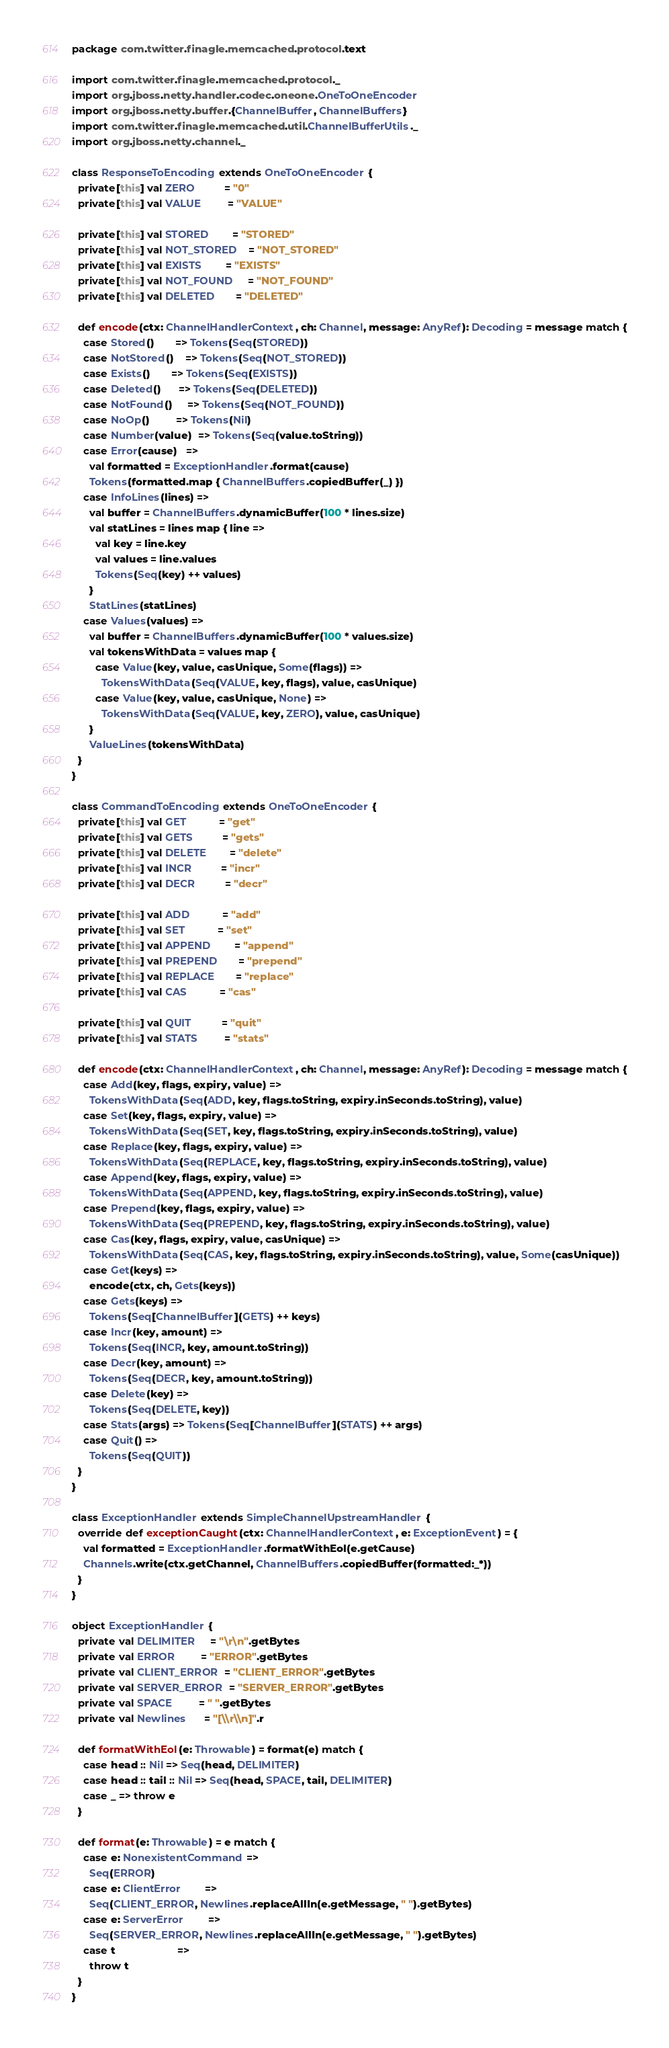<code> <loc_0><loc_0><loc_500><loc_500><_Scala_>package com.twitter.finagle.memcached.protocol.text

import com.twitter.finagle.memcached.protocol._
import org.jboss.netty.handler.codec.oneone.OneToOneEncoder
import org.jboss.netty.buffer.{ChannelBuffer, ChannelBuffers}
import com.twitter.finagle.memcached.util.ChannelBufferUtils._
import org.jboss.netty.channel._

class ResponseToEncoding extends OneToOneEncoder {
  private[this] val ZERO          = "0"
  private[this] val VALUE         = "VALUE"

  private[this] val STORED        = "STORED"
  private[this] val NOT_STORED    = "NOT_STORED"
  private[this] val EXISTS        = "EXISTS"
  private[this] val NOT_FOUND     = "NOT_FOUND"
  private[this] val DELETED       = "DELETED"

  def encode(ctx: ChannelHandlerContext, ch: Channel, message: AnyRef): Decoding = message match {
    case Stored()       => Tokens(Seq(STORED))
    case NotStored()    => Tokens(Seq(NOT_STORED))
    case Exists()       => Tokens(Seq(EXISTS))
    case Deleted()      => Tokens(Seq(DELETED))
    case NotFound()     => Tokens(Seq(NOT_FOUND))
    case NoOp()         => Tokens(Nil)
    case Number(value)  => Tokens(Seq(value.toString))
    case Error(cause)   =>
      val formatted = ExceptionHandler.format(cause)
      Tokens(formatted.map { ChannelBuffers.copiedBuffer(_) })
    case InfoLines(lines) =>
      val buffer = ChannelBuffers.dynamicBuffer(100 * lines.size)
      val statLines = lines map { line =>
        val key = line.key
        val values = line.values
        Tokens(Seq(key) ++ values)
      }
      StatLines(statLines)
    case Values(values) =>
      val buffer = ChannelBuffers.dynamicBuffer(100 * values.size)
      val tokensWithData = values map {
        case Value(key, value, casUnique, Some(flags)) =>
          TokensWithData(Seq(VALUE, key, flags), value, casUnique)
        case Value(key, value, casUnique, None) =>
          TokensWithData(Seq(VALUE, key, ZERO), value, casUnique)
      }
      ValueLines(tokensWithData)
  }
}

class CommandToEncoding extends OneToOneEncoder {
  private[this] val GET           = "get"
  private[this] val GETS          = "gets"
  private[this] val DELETE        = "delete"
  private[this] val INCR          = "incr"
  private[this] val DECR          = "decr"

  private[this] val ADD           = "add"
  private[this] val SET           = "set"
  private[this] val APPEND        = "append"
  private[this] val PREPEND       = "prepend"
  private[this] val REPLACE       = "replace"
  private[this] val CAS           = "cas"

  private[this] val QUIT          = "quit"
  private[this] val STATS         = "stats"

  def encode(ctx: ChannelHandlerContext, ch: Channel, message: AnyRef): Decoding = message match {
    case Add(key, flags, expiry, value) =>
      TokensWithData(Seq(ADD, key, flags.toString, expiry.inSeconds.toString), value)
    case Set(key, flags, expiry, value) =>
      TokensWithData(Seq(SET, key, flags.toString, expiry.inSeconds.toString), value)
    case Replace(key, flags, expiry, value) =>
      TokensWithData(Seq(REPLACE, key, flags.toString, expiry.inSeconds.toString), value)
    case Append(key, flags, expiry, value) =>
      TokensWithData(Seq(APPEND, key, flags.toString, expiry.inSeconds.toString), value)
    case Prepend(key, flags, expiry, value) =>
      TokensWithData(Seq(PREPEND, key, flags.toString, expiry.inSeconds.toString), value)
    case Cas(key, flags, expiry, value, casUnique) =>
      TokensWithData(Seq(CAS, key, flags.toString, expiry.inSeconds.toString), value, Some(casUnique))
    case Get(keys) =>
      encode(ctx, ch, Gets(keys))
    case Gets(keys) =>
      Tokens(Seq[ChannelBuffer](GETS) ++ keys)
    case Incr(key, amount) =>
      Tokens(Seq(INCR, key, amount.toString))
    case Decr(key, amount) =>
      Tokens(Seq(DECR, key, amount.toString))
    case Delete(key) =>
      Tokens(Seq(DELETE, key))
    case Stats(args) => Tokens(Seq[ChannelBuffer](STATS) ++ args)
    case Quit() =>
      Tokens(Seq(QUIT))
  }
}

class ExceptionHandler extends SimpleChannelUpstreamHandler {
  override def exceptionCaught(ctx: ChannelHandlerContext, e: ExceptionEvent) = {
    val formatted = ExceptionHandler.formatWithEol(e.getCause)
    Channels.write(ctx.getChannel, ChannelBuffers.copiedBuffer(formatted:_*))
  }
}

object ExceptionHandler {
  private val DELIMITER     = "\r\n".getBytes
  private val ERROR         = "ERROR".getBytes
  private val CLIENT_ERROR  = "CLIENT_ERROR".getBytes
  private val SERVER_ERROR  = "SERVER_ERROR".getBytes
  private val SPACE         = " ".getBytes
  private val Newlines      = "[\\r\\n]".r

  def formatWithEol(e: Throwable) = format(e) match {
    case head :: Nil => Seq(head, DELIMITER)
    case head :: tail :: Nil => Seq(head, SPACE, tail, DELIMITER)
    case _ => throw e
  }

  def format(e: Throwable) = e match {
    case e: NonexistentCommand =>
      Seq(ERROR)
    case e: ClientError        =>
      Seq(CLIENT_ERROR, Newlines.replaceAllIn(e.getMessage, " ").getBytes)
    case e: ServerError        =>
      Seq(SERVER_ERROR, Newlines.replaceAllIn(e.getMessage, " ").getBytes)
    case t                     =>
      throw t
  }
}
</code> 